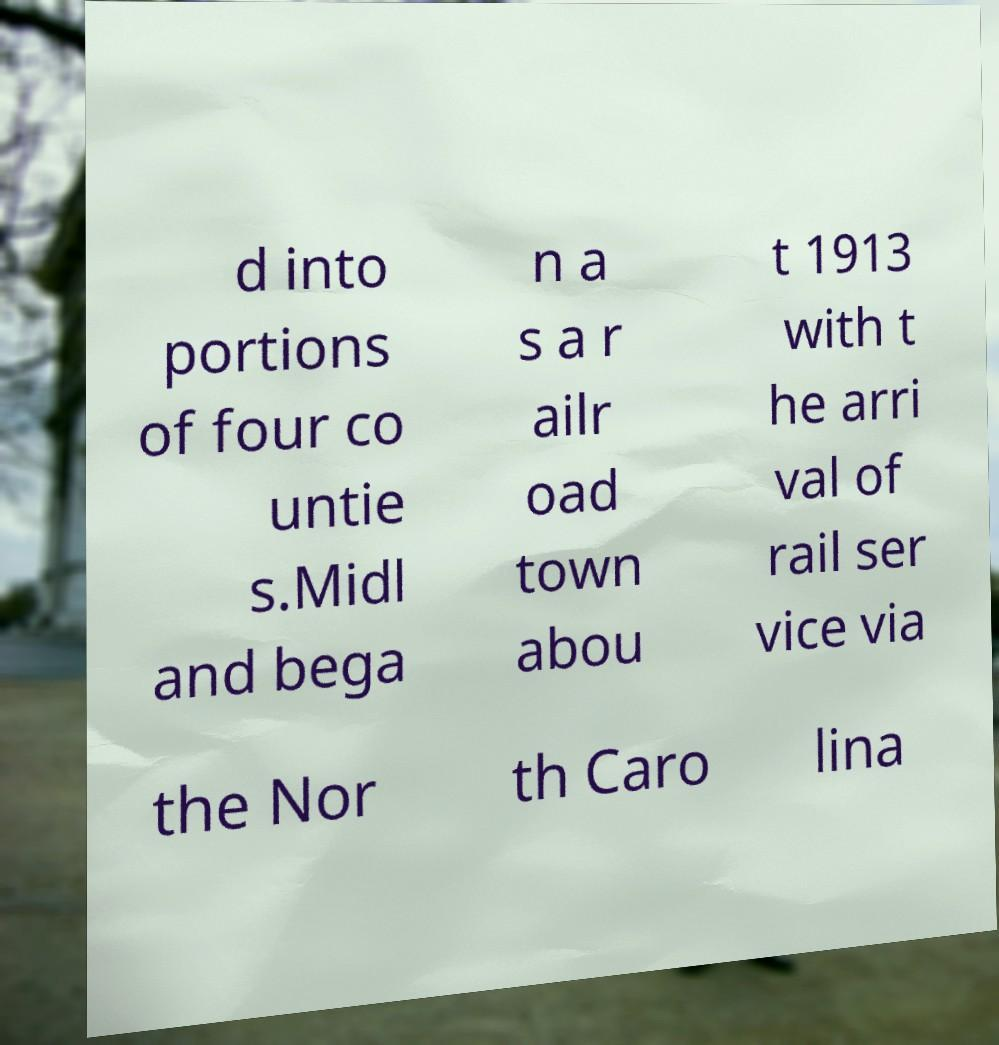For documentation purposes, I need the text within this image transcribed. Could you provide that? d into portions of four co untie s.Midl and bega n a s a r ailr oad town abou t 1913 with t he arri val of rail ser vice via the Nor th Caro lina 